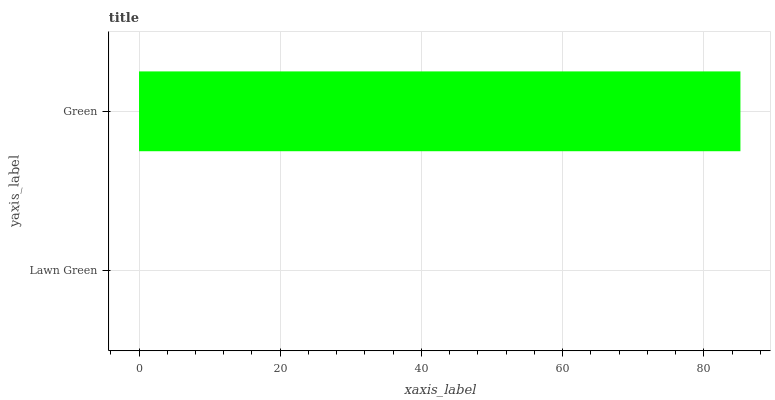Is Lawn Green the minimum?
Answer yes or no. Yes. Is Green the maximum?
Answer yes or no. Yes. Is Green the minimum?
Answer yes or no. No. Is Green greater than Lawn Green?
Answer yes or no. Yes. Is Lawn Green less than Green?
Answer yes or no. Yes. Is Lawn Green greater than Green?
Answer yes or no. No. Is Green less than Lawn Green?
Answer yes or no. No. Is Green the high median?
Answer yes or no. Yes. Is Lawn Green the low median?
Answer yes or no. Yes. Is Lawn Green the high median?
Answer yes or no. No. Is Green the low median?
Answer yes or no. No. 